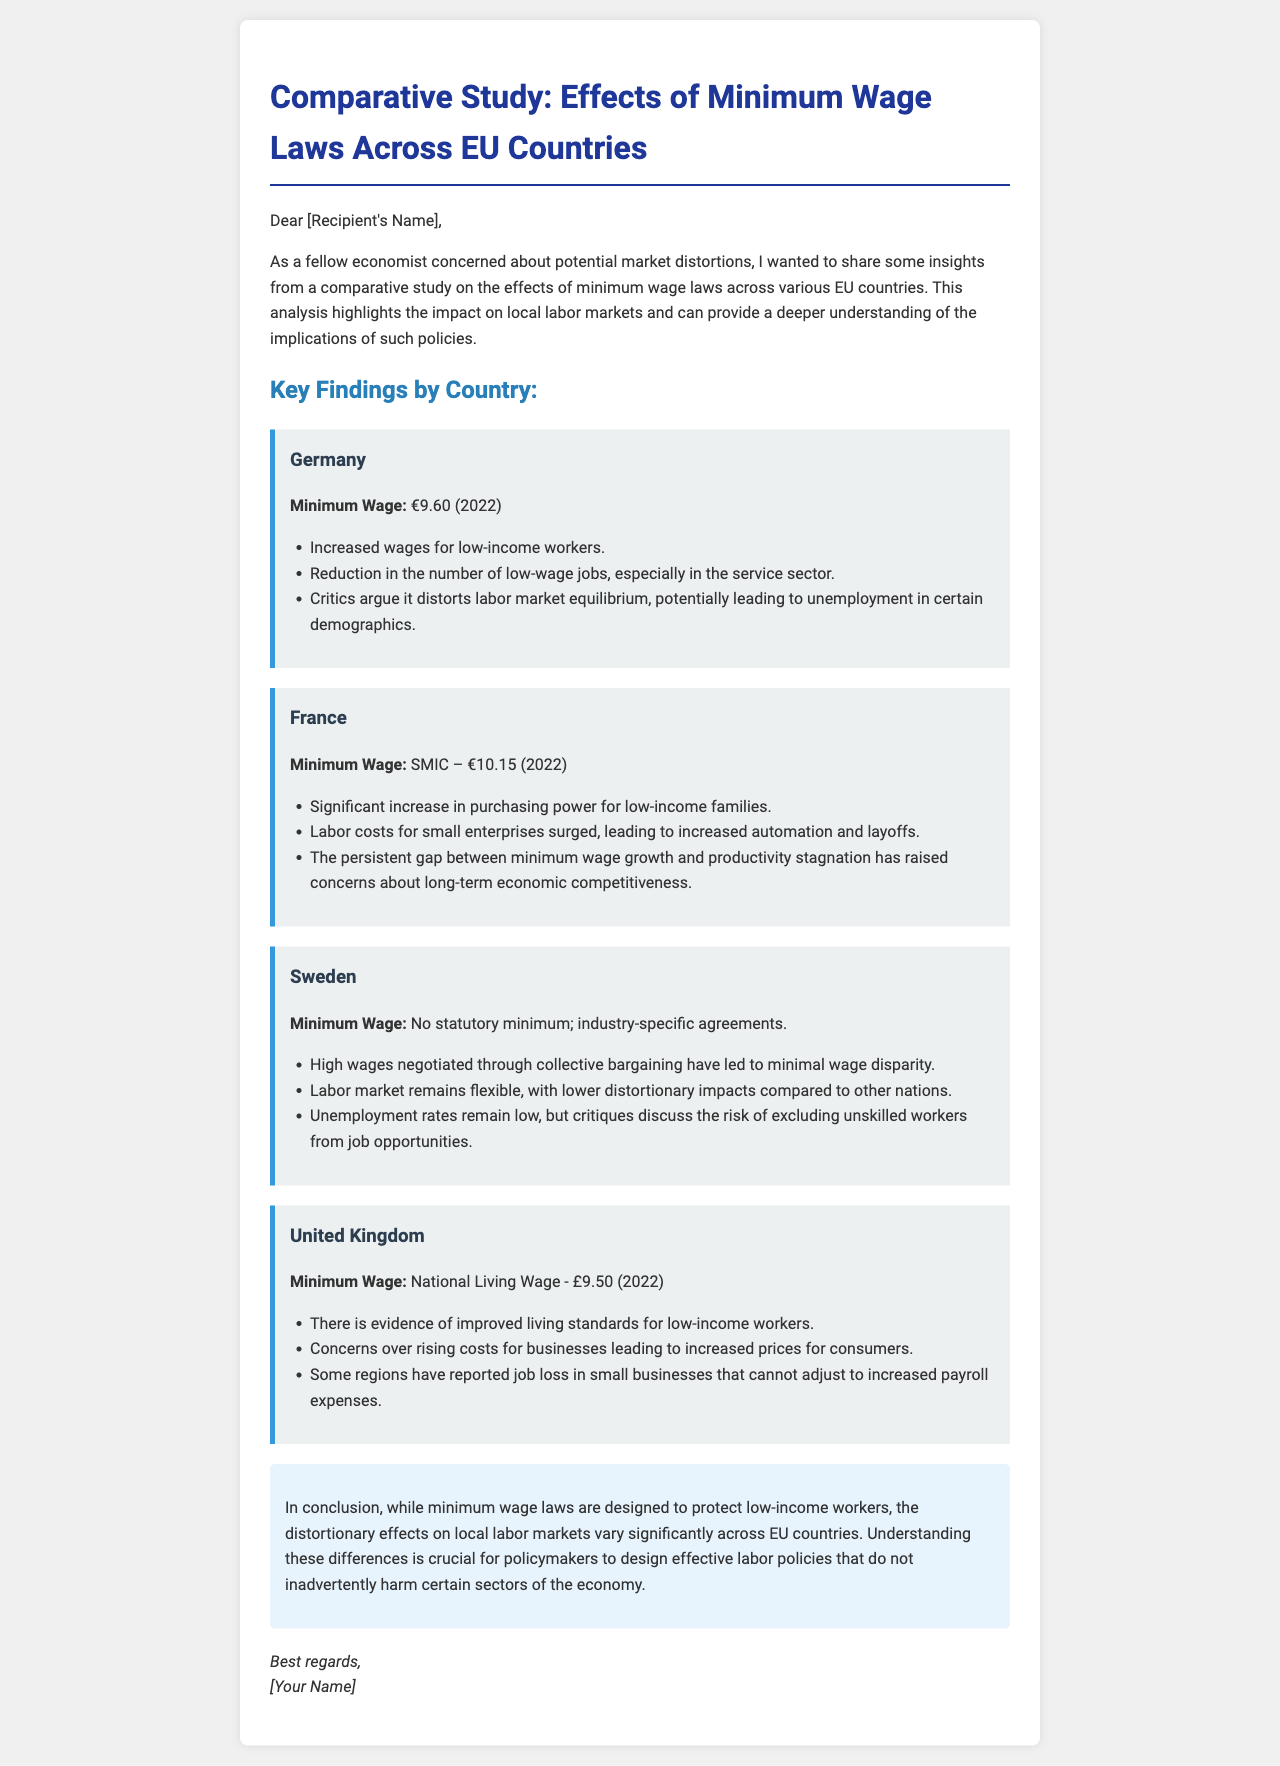What is the minimum wage in Germany? The document specifies the minimum wage in Germany as €9.60 (2022).
Answer: €9.60 What is the concern raised about the minimum wage in France? The document mentions that the labor costs for small enterprises surged, leading to increased automation and layoffs.
Answer: Increased automation and layoffs What is the minimum wage in the United Kingdom? The document indicates the National Living Wage in the United Kingdom as £9.50 (2022).
Answer: £9.50 How does the labor market in Sweden differ from other countries regarding minimum wage laws? The document states that Sweden has no statutory minimum and relies on industry-specific agreements, leading to lower distortionary impacts.
Answer: No statutory minimum What are the effects of minimum wage laws on unemployment in Germany? The document notes that critics argue minimum wage laws could lead to unemployment in certain demographics.
Answer: Unemployment in certain demographics What is one consequence of the persistent gap between minimum wage growth and productivity in France? The document points out that this gap has raised concerns about long-term economic competitiveness.
Answer: Long-term economic competitiveness What is the aim of the document? The document aims to present insights from a comparative study on the effects of minimum wage laws across EU countries.
Answer: Comparative study on minimum wage laws What should policymakers understand about minimum wage laws according to the conclusion? The conclusion emphasizes the need for policymakers to understand the differences in distortionary effects across EU countries.
Answer: Distortionary effects across EU countries 